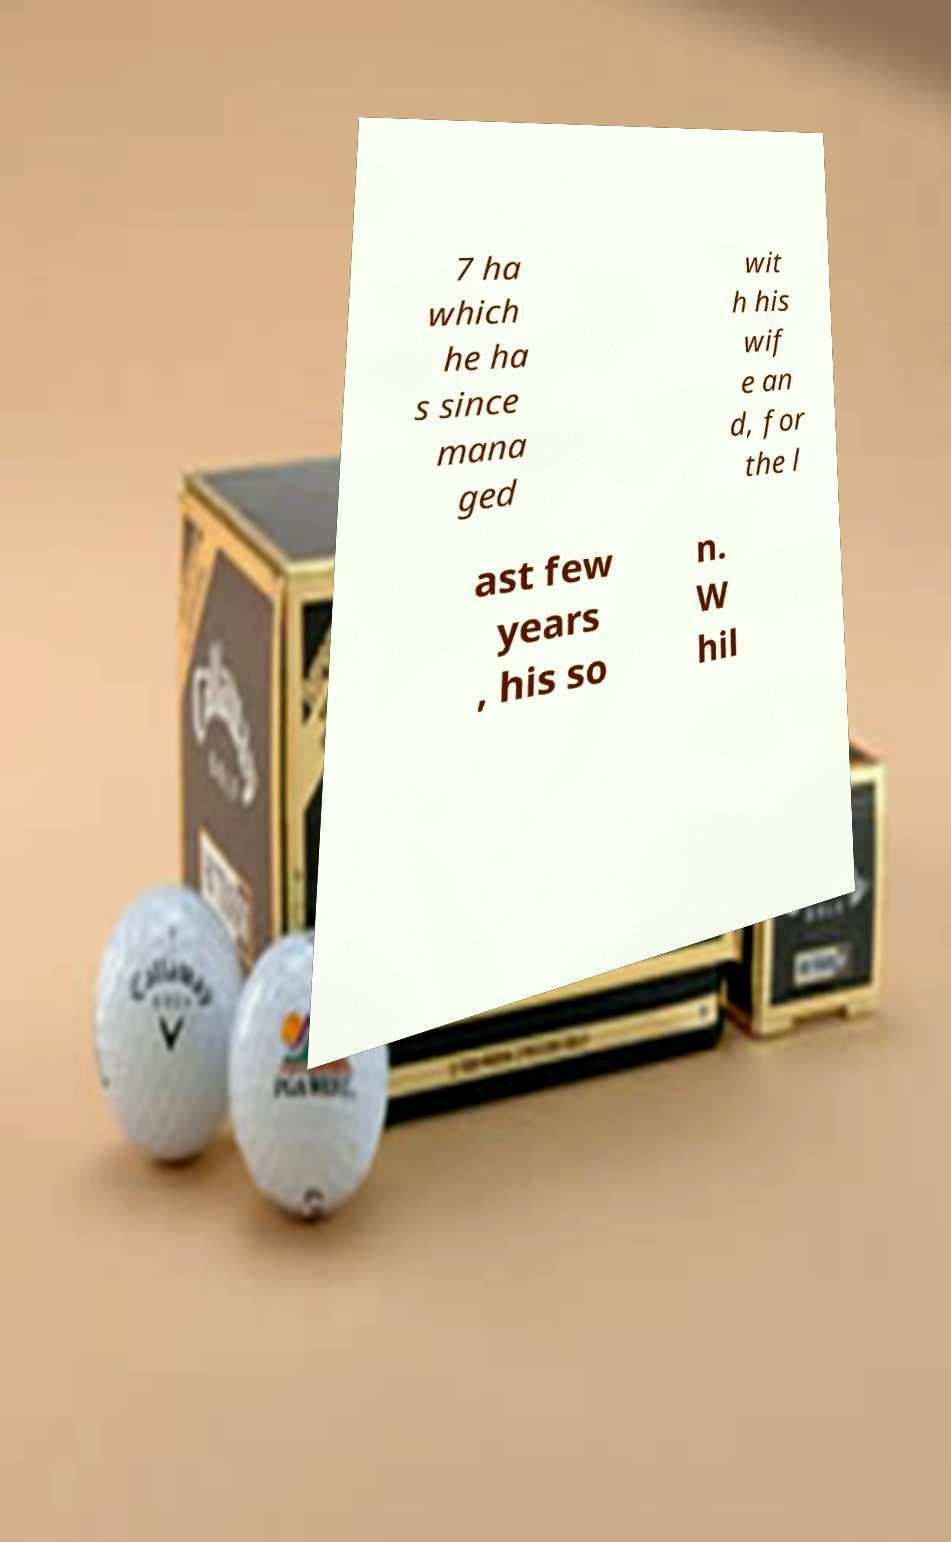There's text embedded in this image that I need extracted. Can you transcribe it verbatim? 7 ha which he ha s since mana ged wit h his wif e an d, for the l ast few years , his so n. W hil 